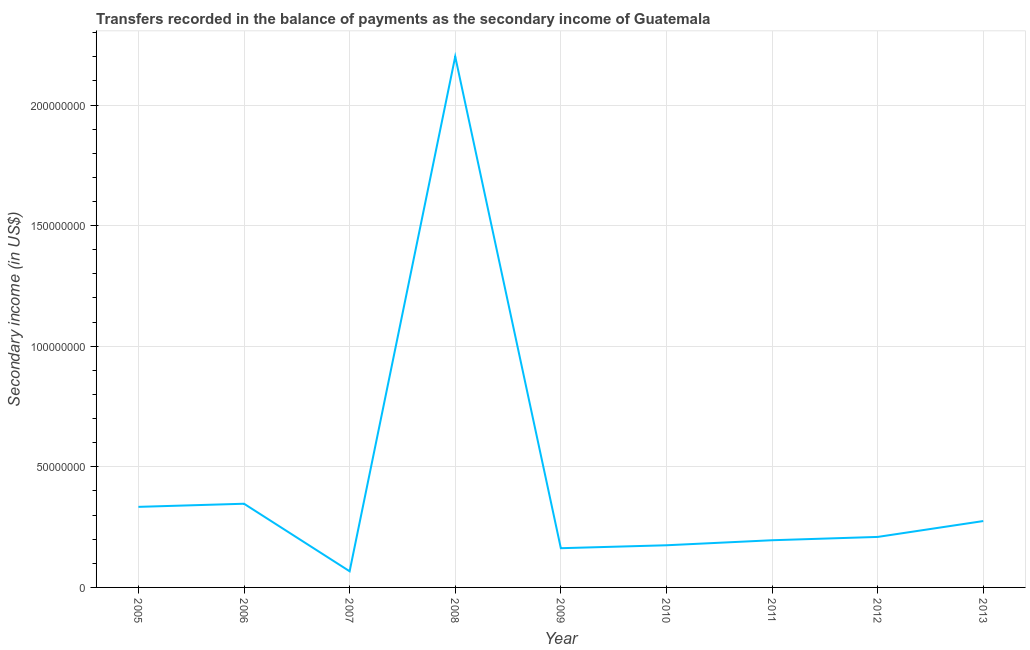What is the amount of secondary income in 2009?
Your answer should be very brief. 1.63e+07. Across all years, what is the maximum amount of secondary income?
Give a very brief answer. 2.20e+08. Across all years, what is the minimum amount of secondary income?
Make the answer very short. 6.70e+06. In which year was the amount of secondary income maximum?
Your response must be concise. 2008. In which year was the amount of secondary income minimum?
Offer a terse response. 2007. What is the sum of the amount of secondary income?
Offer a terse response. 3.97e+08. What is the difference between the amount of secondary income in 2007 and 2013?
Offer a terse response. -2.08e+07. What is the average amount of secondary income per year?
Make the answer very short. 4.41e+07. What is the median amount of secondary income?
Your answer should be compact. 2.09e+07. In how many years, is the amount of secondary income greater than 110000000 US$?
Keep it short and to the point. 1. What is the ratio of the amount of secondary income in 2005 to that in 2010?
Your answer should be compact. 1.91. Is the amount of secondary income in 2005 less than that in 2010?
Keep it short and to the point. No. Is the difference between the amount of secondary income in 2006 and 2009 greater than the difference between any two years?
Your answer should be very brief. No. What is the difference between the highest and the second highest amount of secondary income?
Your answer should be compact. 1.85e+08. What is the difference between the highest and the lowest amount of secondary income?
Make the answer very short. 2.13e+08. In how many years, is the amount of secondary income greater than the average amount of secondary income taken over all years?
Provide a short and direct response. 1. How many lines are there?
Your answer should be very brief. 1. How many years are there in the graph?
Offer a very short reply. 9. Are the values on the major ticks of Y-axis written in scientific E-notation?
Give a very brief answer. No. Does the graph contain grids?
Provide a short and direct response. Yes. What is the title of the graph?
Offer a terse response. Transfers recorded in the balance of payments as the secondary income of Guatemala. What is the label or title of the Y-axis?
Offer a terse response. Secondary income (in US$). What is the Secondary income (in US$) in 2005?
Offer a terse response. 3.34e+07. What is the Secondary income (in US$) of 2006?
Keep it short and to the point. 3.47e+07. What is the Secondary income (in US$) of 2007?
Your answer should be compact. 6.70e+06. What is the Secondary income (in US$) in 2008?
Your response must be concise. 2.20e+08. What is the Secondary income (in US$) in 2009?
Provide a short and direct response. 1.63e+07. What is the Secondary income (in US$) in 2010?
Your answer should be compact. 1.75e+07. What is the Secondary income (in US$) of 2011?
Make the answer very short. 1.96e+07. What is the Secondary income (in US$) in 2012?
Your answer should be very brief. 2.09e+07. What is the Secondary income (in US$) of 2013?
Your answer should be compact. 2.75e+07. What is the difference between the Secondary income (in US$) in 2005 and 2006?
Give a very brief answer. -1.30e+06. What is the difference between the Secondary income (in US$) in 2005 and 2007?
Provide a succinct answer. 2.67e+07. What is the difference between the Secondary income (in US$) in 2005 and 2008?
Provide a succinct answer. -1.87e+08. What is the difference between the Secondary income (in US$) in 2005 and 2009?
Provide a short and direct response. 1.71e+07. What is the difference between the Secondary income (in US$) in 2005 and 2010?
Ensure brevity in your answer.  1.59e+07. What is the difference between the Secondary income (in US$) in 2005 and 2011?
Provide a short and direct response. 1.38e+07. What is the difference between the Secondary income (in US$) in 2005 and 2012?
Offer a terse response. 1.25e+07. What is the difference between the Secondary income (in US$) in 2005 and 2013?
Your answer should be very brief. 5.88e+06. What is the difference between the Secondary income (in US$) in 2006 and 2007?
Offer a very short reply. 2.80e+07. What is the difference between the Secondary income (in US$) in 2006 and 2008?
Provide a short and direct response. -1.85e+08. What is the difference between the Secondary income (in US$) in 2006 and 2009?
Your response must be concise. 1.84e+07. What is the difference between the Secondary income (in US$) in 2006 and 2010?
Your answer should be very brief. 1.72e+07. What is the difference between the Secondary income (in US$) in 2006 and 2011?
Give a very brief answer. 1.51e+07. What is the difference between the Secondary income (in US$) in 2006 and 2012?
Provide a succinct answer. 1.38e+07. What is the difference between the Secondary income (in US$) in 2006 and 2013?
Offer a terse response. 7.18e+06. What is the difference between the Secondary income (in US$) in 2007 and 2008?
Give a very brief answer. -2.13e+08. What is the difference between the Secondary income (in US$) in 2007 and 2009?
Provide a short and direct response. -9.56e+06. What is the difference between the Secondary income (in US$) in 2007 and 2010?
Give a very brief answer. -1.08e+07. What is the difference between the Secondary income (in US$) in 2007 and 2011?
Make the answer very short. -1.29e+07. What is the difference between the Secondary income (in US$) in 2007 and 2012?
Offer a terse response. -1.42e+07. What is the difference between the Secondary income (in US$) in 2007 and 2013?
Keep it short and to the point. -2.08e+07. What is the difference between the Secondary income (in US$) in 2008 and 2009?
Ensure brevity in your answer.  2.04e+08. What is the difference between the Secondary income (in US$) in 2008 and 2010?
Provide a succinct answer. 2.03e+08. What is the difference between the Secondary income (in US$) in 2008 and 2011?
Ensure brevity in your answer.  2.01e+08. What is the difference between the Secondary income (in US$) in 2008 and 2012?
Make the answer very short. 1.99e+08. What is the difference between the Secondary income (in US$) in 2008 and 2013?
Your answer should be compact. 1.93e+08. What is the difference between the Secondary income (in US$) in 2009 and 2010?
Offer a very short reply. -1.21e+06. What is the difference between the Secondary income (in US$) in 2009 and 2011?
Give a very brief answer. -3.30e+06. What is the difference between the Secondary income (in US$) in 2009 and 2012?
Give a very brief answer. -4.67e+06. What is the difference between the Secondary income (in US$) in 2009 and 2013?
Keep it short and to the point. -1.13e+07. What is the difference between the Secondary income (in US$) in 2010 and 2011?
Offer a terse response. -2.09e+06. What is the difference between the Secondary income (in US$) in 2010 and 2012?
Your answer should be compact. -3.46e+06. What is the difference between the Secondary income (in US$) in 2010 and 2013?
Provide a short and direct response. -1.00e+07. What is the difference between the Secondary income (in US$) in 2011 and 2012?
Provide a succinct answer. -1.37e+06. What is the difference between the Secondary income (in US$) in 2011 and 2013?
Make the answer very short. -7.95e+06. What is the difference between the Secondary income (in US$) in 2012 and 2013?
Offer a very short reply. -6.58e+06. What is the ratio of the Secondary income (in US$) in 2005 to that in 2006?
Offer a very short reply. 0.96. What is the ratio of the Secondary income (in US$) in 2005 to that in 2007?
Give a very brief answer. 4.99. What is the ratio of the Secondary income (in US$) in 2005 to that in 2008?
Offer a terse response. 0.15. What is the ratio of the Secondary income (in US$) in 2005 to that in 2009?
Your answer should be very brief. 2.05. What is the ratio of the Secondary income (in US$) in 2005 to that in 2010?
Your answer should be compact. 1.91. What is the ratio of the Secondary income (in US$) in 2005 to that in 2011?
Keep it short and to the point. 1.71. What is the ratio of the Secondary income (in US$) in 2005 to that in 2012?
Provide a succinct answer. 1.59. What is the ratio of the Secondary income (in US$) in 2005 to that in 2013?
Offer a very short reply. 1.21. What is the ratio of the Secondary income (in US$) in 2006 to that in 2007?
Keep it short and to the point. 5.18. What is the ratio of the Secondary income (in US$) in 2006 to that in 2008?
Provide a short and direct response. 0.16. What is the ratio of the Secondary income (in US$) in 2006 to that in 2009?
Offer a very short reply. 2.13. What is the ratio of the Secondary income (in US$) in 2006 to that in 2010?
Give a very brief answer. 1.99. What is the ratio of the Secondary income (in US$) in 2006 to that in 2011?
Ensure brevity in your answer.  1.77. What is the ratio of the Secondary income (in US$) in 2006 to that in 2012?
Provide a short and direct response. 1.66. What is the ratio of the Secondary income (in US$) in 2006 to that in 2013?
Provide a succinct answer. 1.26. What is the ratio of the Secondary income (in US$) in 2007 to that in 2009?
Make the answer very short. 0.41. What is the ratio of the Secondary income (in US$) in 2007 to that in 2010?
Keep it short and to the point. 0.38. What is the ratio of the Secondary income (in US$) in 2007 to that in 2011?
Give a very brief answer. 0.34. What is the ratio of the Secondary income (in US$) in 2007 to that in 2012?
Provide a succinct answer. 0.32. What is the ratio of the Secondary income (in US$) in 2007 to that in 2013?
Your answer should be compact. 0.24. What is the ratio of the Secondary income (in US$) in 2008 to that in 2009?
Make the answer very short. 13.53. What is the ratio of the Secondary income (in US$) in 2008 to that in 2010?
Keep it short and to the point. 12.59. What is the ratio of the Secondary income (in US$) in 2008 to that in 2011?
Offer a terse response. 11.25. What is the ratio of the Secondary income (in US$) in 2008 to that in 2012?
Provide a short and direct response. 10.51. What is the ratio of the Secondary income (in US$) in 2008 to that in 2013?
Give a very brief answer. 8. What is the ratio of the Secondary income (in US$) in 2009 to that in 2010?
Offer a very short reply. 0.93. What is the ratio of the Secondary income (in US$) in 2009 to that in 2011?
Offer a very short reply. 0.83. What is the ratio of the Secondary income (in US$) in 2009 to that in 2012?
Keep it short and to the point. 0.78. What is the ratio of the Secondary income (in US$) in 2009 to that in 2013?
Make the answer very short. 0.59. What is the ratio of the Secondary income (in US$) in 2010 to that in 2011?
Provide a short and direct response. 0.89. What is the ratio of the Secondary income (in US$) in 2010 to that in 2012?
Make the answer very short. 0.83. What is the ratio of the Secondary income (in US$) in 2010 to that in 2013?
Your response must be concise. 0.64. What is the ratio of the Secondary income (in US$) in 2011 to that in 2012?
Make the answer very short. 0.93. What is the ratio of the Secondary income (in US$) in 2011 to that in 2013?
Ensure brevity in your answer.  0.71. What is the ratio of the Secondary income (in US$) in 2012 to that in 2013?
Ensure brevity in your answer.  0.76. 